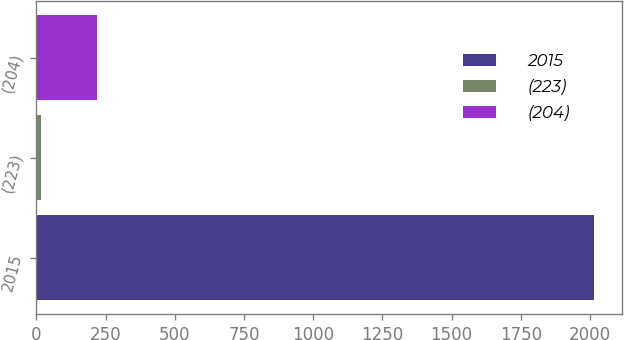Convert chart. <chart><loc_0><loc_0><loc_500><loc_500><bar_chart><fcel>2015<fcel>(223)<fcel>(204)<nl><fcel>2014<fcel>18<fcel>217.6<nl></chart> 